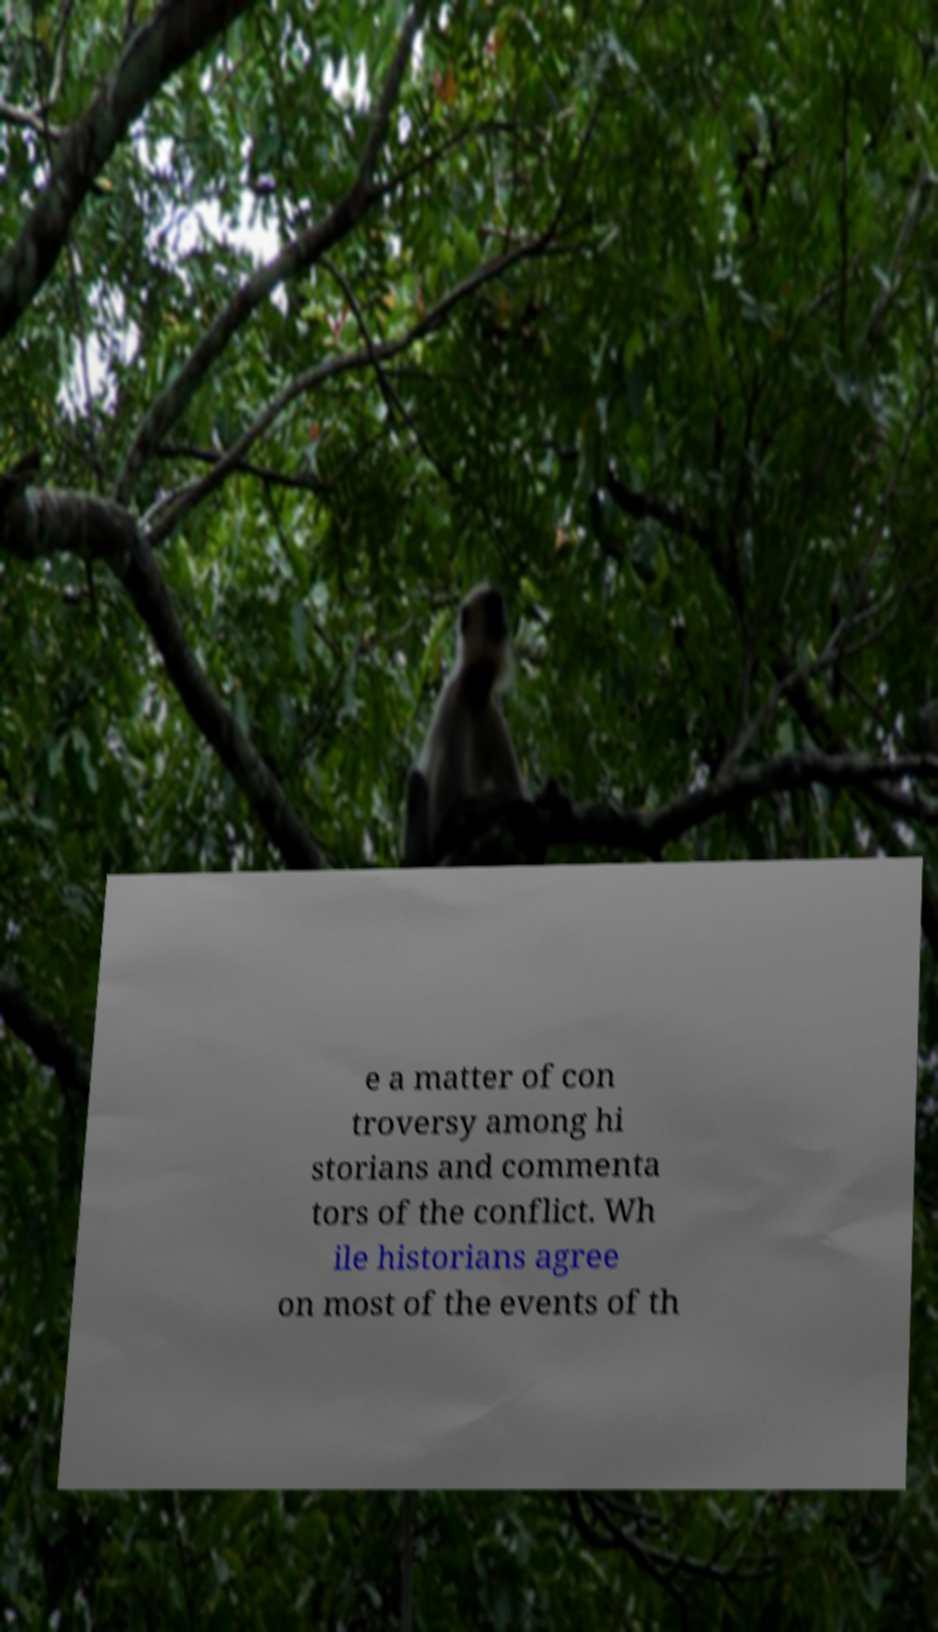Can you read and provide the text displayed in the image?This photo seems to have some interesting text. Can you extract and type it out for me? e a matter of con troversy among hi storians and commenta tors of the conflict. Wh ile historians agree on most of the events of th 